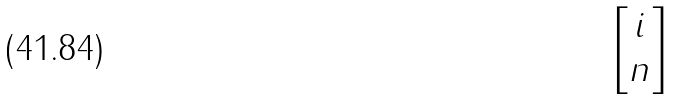Convert formula to latex. <formula><loc_0><loc_0><loc_500><loc_500>\begin{bmatrix} i \\ n \end{bmatrix}</formula> 